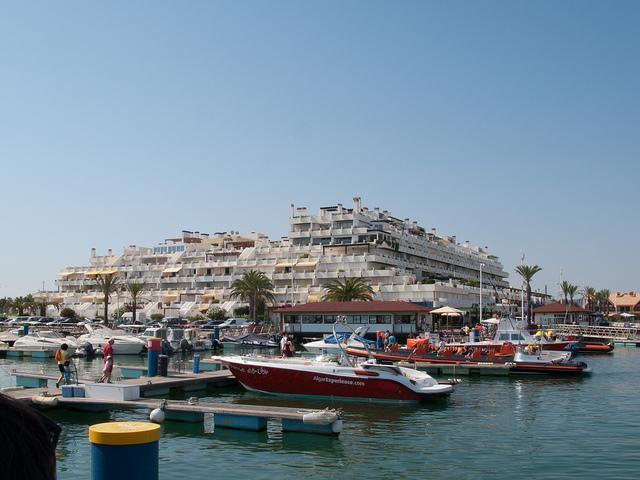How many people are standing under the red boat?
Give a very brief answer. 0. How many boats are in the picture?
Give a very brief answer. 2. How many clocks are here?
Give a very brief answer. 0. 